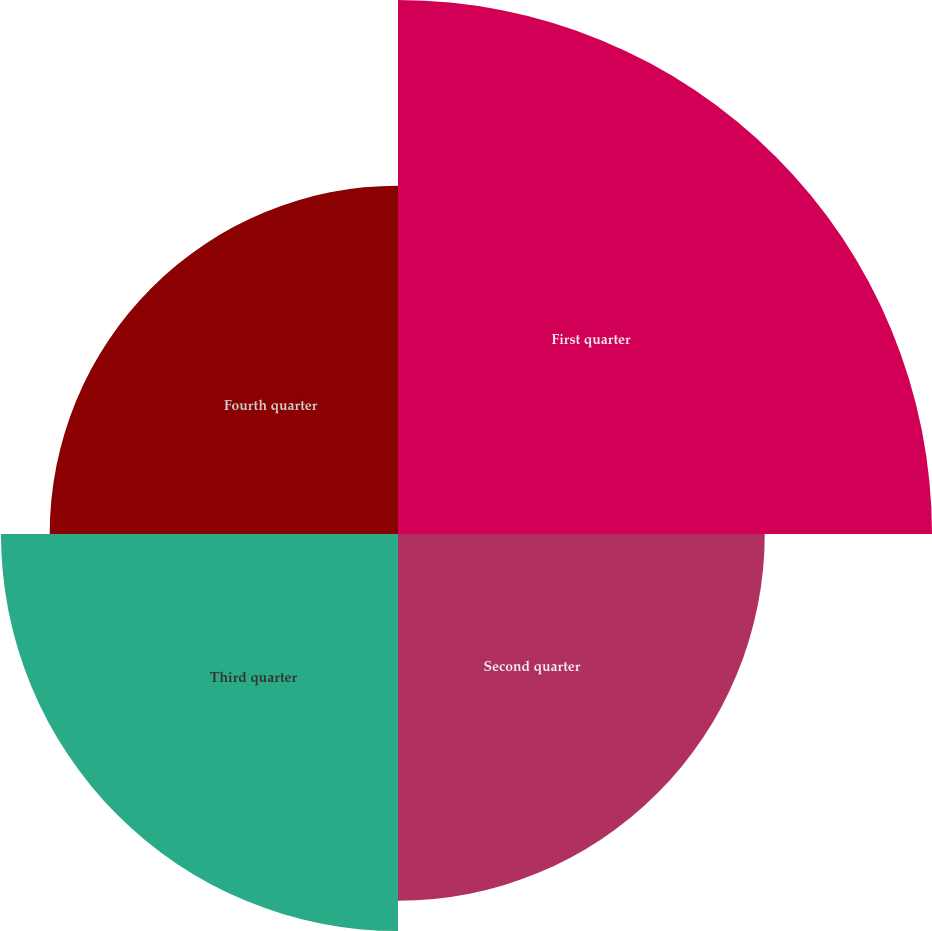Convert chart to OTSL. <chart><loc_0><loc_0><loc_500><loc_500><pie_chart><fcel>First quarter<fcel>Second quarter<fcel>Third quarter<fcel>Fourth quarter<nl><fcel>32.44%<fcel>22.28%<fcel>24.12%<fcel>21.16%<nl></chart> 